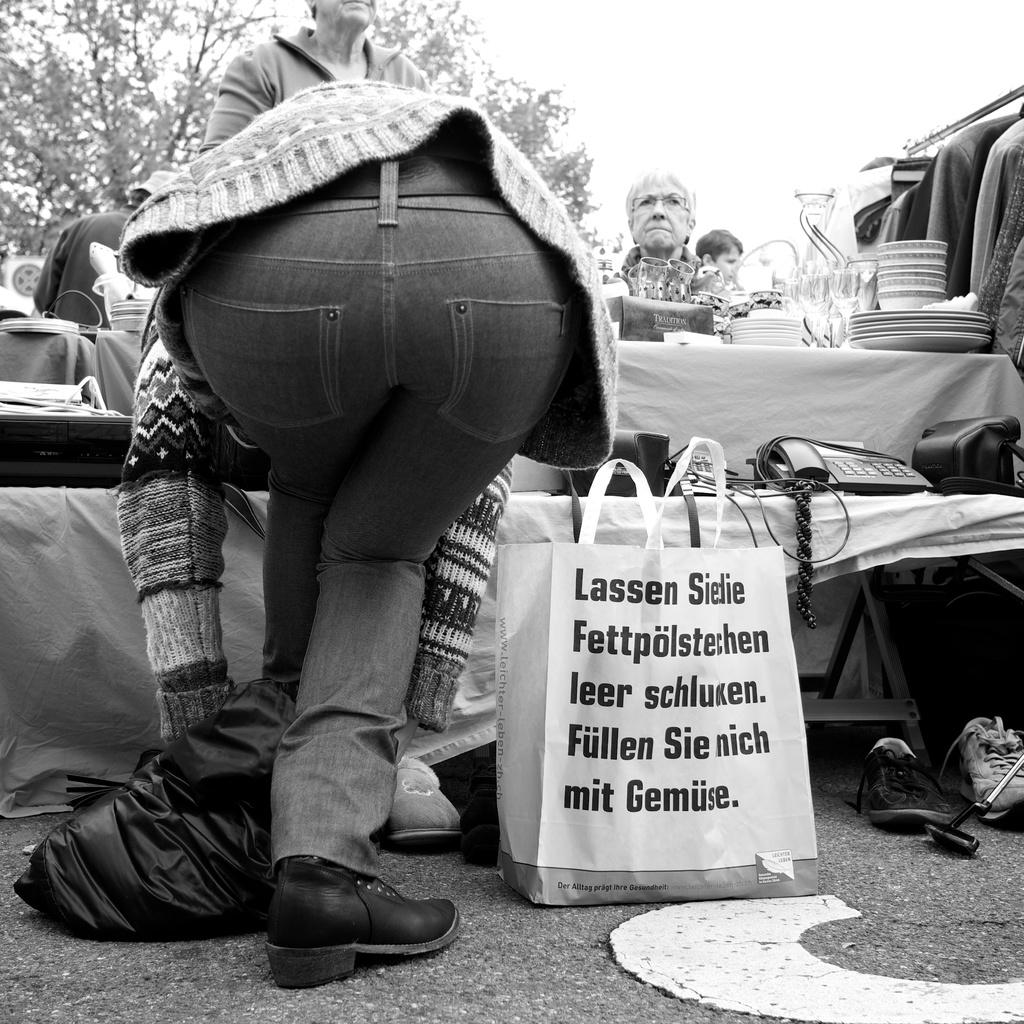<image>
Summarize the visual content of the image. a person has a bag sitting on the ground by them with Lassen Sielie written on the top 